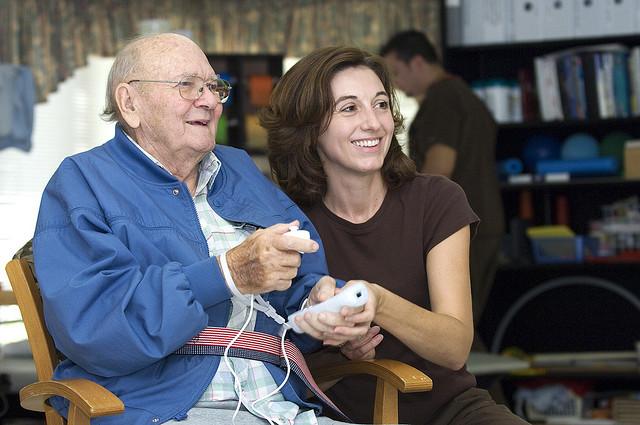Is the girl helping the older gentleman?
Short answer required. Yes. Are these people the same age?
Be succinct. No. Are they enjoying themselves?
Answer briefly. Yes. 